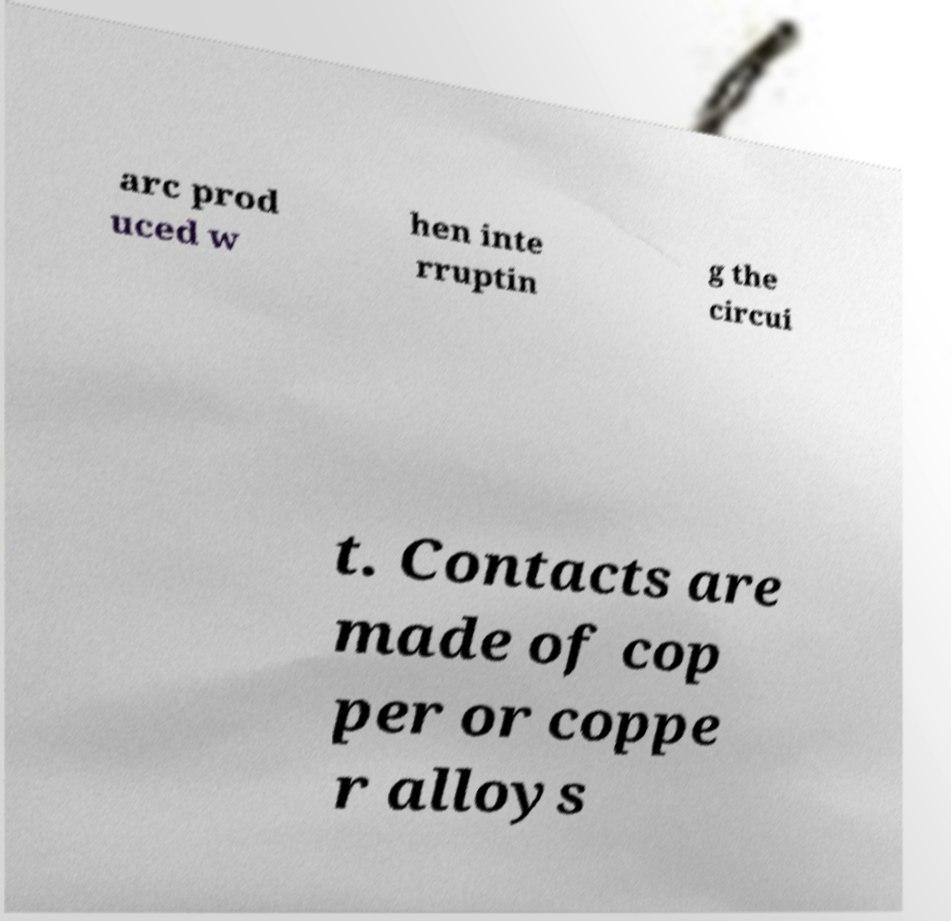I need the written content from this picture converted into text. Can you do that? arc prod uced w hen inte rruptin g the circui t. Contacts are made of cop per or coppe r alloys 